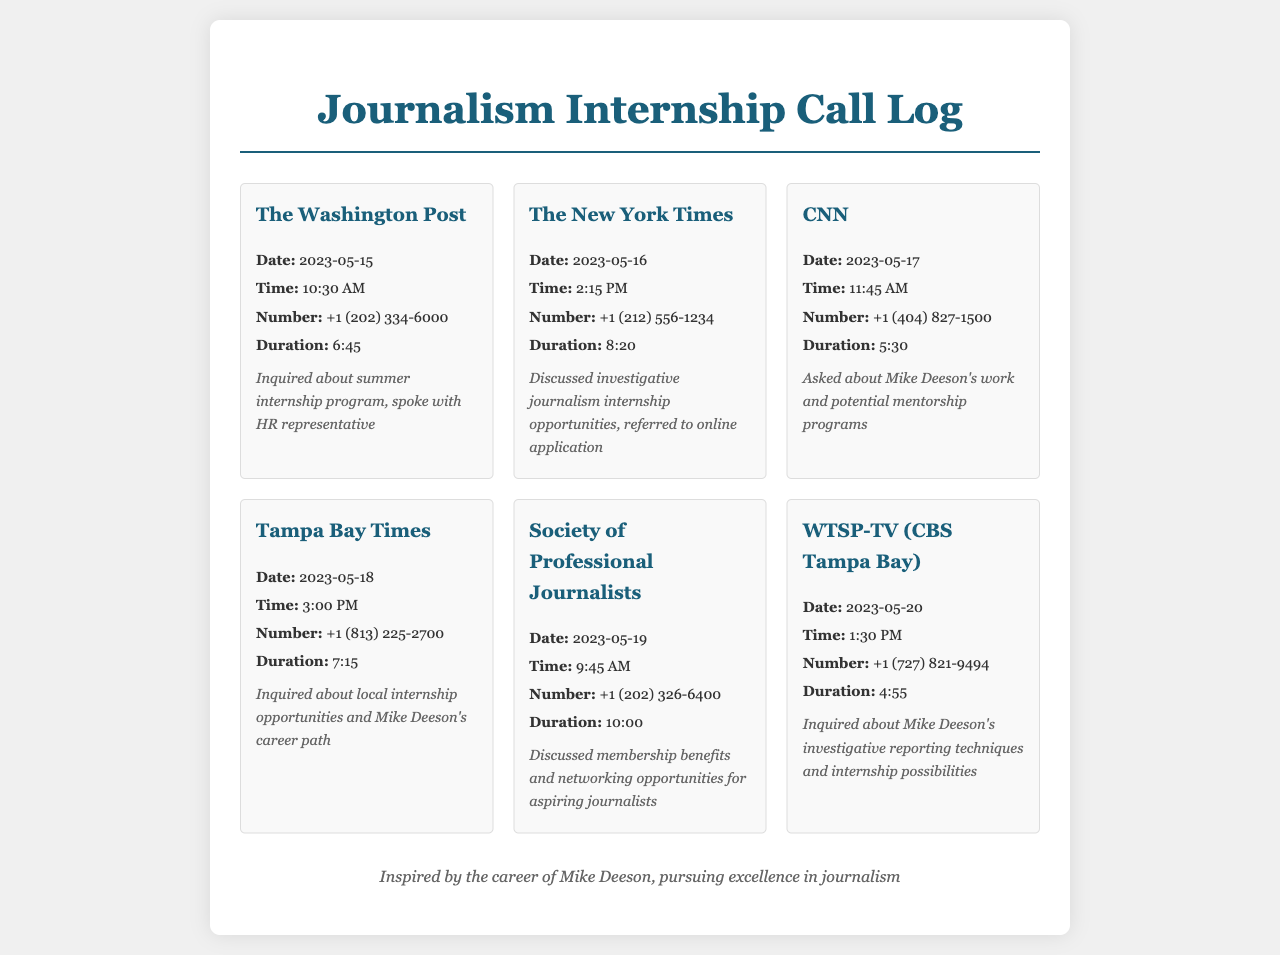What is the duration of the call to The Washington Post? The duration is specified for each call, and for The Washington Post it is 6:45.
Answer: 6:45 On what date was the call made to The New York Times? The document provides the date of each call, and the call to The New York Times was made on 2023-05-16.
Answer: 2023-05-16 Who did the caller speak with during the call to CNN? The notes for each call mention who was spoken to, and for CNN it states "spoke with HR representative."
Answer: HR representative How long was the call to the Society of Professional Journalists? The duration of the call is noted, and the call to the Society of Professional Journalists lasted 10:00.
Answer: 10:00 What organization was referenced when discussing mentorship programs during the call to CNN? The notes indicate interest in a specific individual's work, and it mentions Mike Deeson when discussing mentorship.
Answer: Mike Deeson How many calls were made on 2023-05-18? The document lists one call for that date, and it was to Tampa Bay Times.
Answer: 1 What was the focus of the inquiry during the call to WTSP-TV (CBS Tampa Bay)? The notes detail the purpose of each call, and for WTSP-TV, it inquired about investigative reporting techniques.
Answer: Investigative reporting techniques What time was the call to the Washington Post made? Each call entry lists the time, and the call to The Washington Post was made at 10:30 AM.
Answer: 10:30 AM Which organization referred to online applications during the call on 2023-05-16? The notes provide insights on conversations, and it was The New York Times that referred to online applications.
Answer: The New York Times 